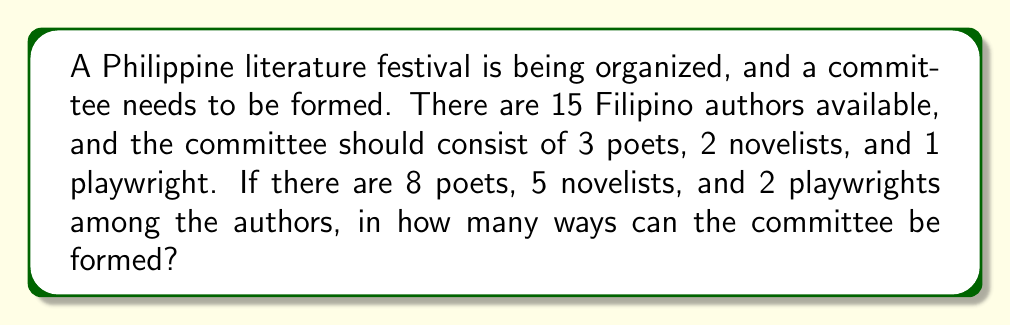Teach me how to tackle this problem. Let's break this down step by step:

1) We need to select:
   - 3 poets out of 8
   - 2 novelists out of 5
   - 1 playwright out of 2

2) For each of these selections, we can use the combination formula:
   $C(n,r) = \frac{n!}{r!(n-r)!}$

3) For the poets:
   $C(8,3) = \frac{8!}{3!(8-3)!} = \frac{8!}{3!5!} = 56$

4) For the novelists:
   $C(5,2) = \frac{5!}{2!(5-2)!} = \frac{5!}{2!3!} = 10$

5) For the playwrights:
   $C(2,1) = \frac{2!}{1!(2-1)!} = \frac{2!}{1!1!} = 2$

6) Now, according to the Multiplication Principle, if we have $m$ ways of doing something, $n$ ways of doing another thing, and $p$ ways of doing a third thing, then there are $m \times n \times p$ ways of doing all three things.

7) Therefore, the total number of ways to form the committee is:
   $56 \times 10 \times 2 = 1120$
Answer: 1120 